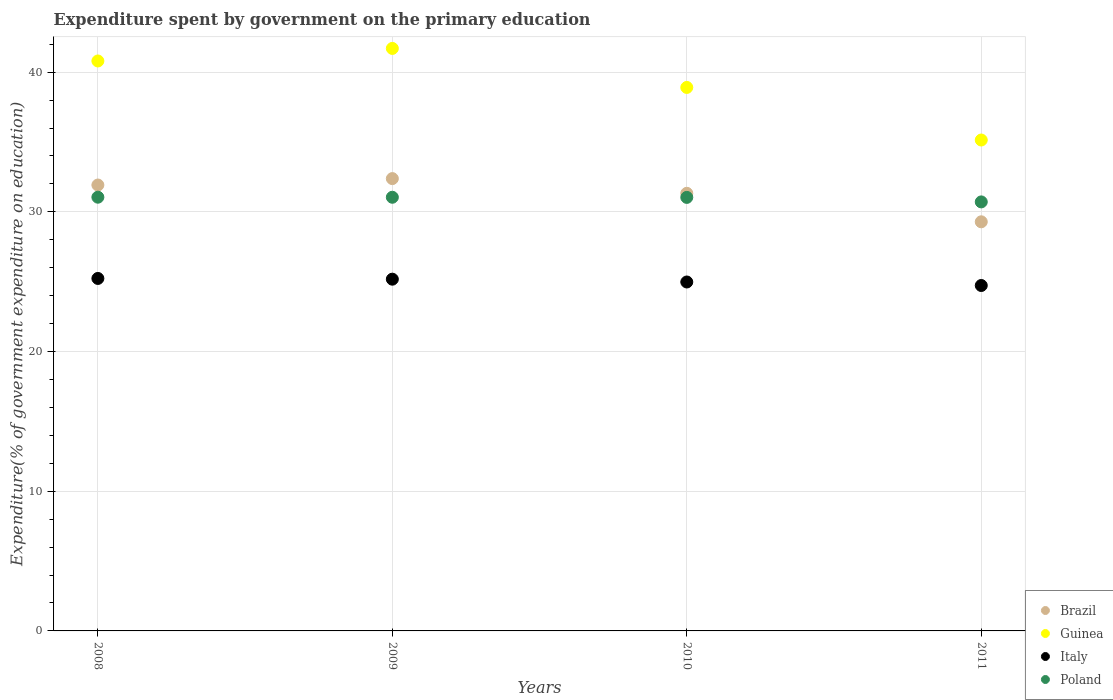Is the number of dotlines equal to the number of legend labels?
Give a very brief answer. Yes. What is the expenditure spent by government on the primary education in Italy in 2010?
Offer a terse response. 24.98. Across all years, what is the maximum expenditure spent by government on the primary education in Guinea?
Provide a succinct answer. 41.7. Across all years, what is the minimum expenditure spent by government on the primary education in Poland?
Make the answer very short. 30.71. In which year was the expenditure spent by government on the primary education in Guinea maximum?
Keep it short and to the point. 2009. In which year was the expenditure spent by government on the primary education in Poland minimum?
Provide a succinct answer. 2011. What is the total expenditure spent by government on the primary education in Italy in the graph?
Make the answer very short. 100.11. What is the difference between the expenditure spent by government on the primary education in Brazil in 2008 and that in 2010?
Make the answer very short. 0.59. What is the difference between the expenditure spent by government on the primary education in Brazil in 2011 and the expenditure spent by government on the primary education in Poland in 2009?
Provide a succinct answer. -1.76. What is the average expenditure spent by government on the primary education in Brazil per year?
Your answer should be compact. 31.23. In the year 2010, what is the difference between the expenditure spent by government on the primary education in Brazil and expenditure spent by government on the primary education in Poland?
Keep it short and to the point. 0.29. In how many years, is the expenditure spent by government on the primary education in Guinea greater than 34 %?
Make the answer very short. 4. What is the ratio of the expenditure spent by government on the primary education in Poland in 2009 to that in 2010?
Make the answer very short. 1. Is the expenditure spent by government on the primary education in Italy in 2009 less than that in 2010?
Your response must be concise. No. What is the difference between the highest and the second highest expenditure spent by government on the primary education in Poland?
Offer a terse response. 0. What is the difference between the highest and the lowest expenditure spent by government on the primary education in Guinea?
Give a very brief answer. 6.56. In how many years, is the expenditure spent by government on the primary education in Poland greater than the average expenditure spent by government on the primary education in Poland taken over all years?
Make the answer very short. 3. Is it the case that in every year, the sum of the expenditure spent by government on the primary education in Brazil and expenditure spent by government on the primary education in Italy  is greater than the expenditure spent by government on the primary education in Poland?
Offer a terse response. Yes. Is the expenditure spent by government on the primary education in Italy strictly less than the expenditure spent by government on the primary education in Guinea over the years?
Give a very brief answer. Yes. What is the difference between two consecutive major ticks on the Y-axis?
Give a very brief answer. 10. Does the graph contain any zero values?
Provide a succinct answer. No. How many legend labels are there?
Give a very brief answer. 4. What is the title of the graph?
Your answer should be very brief. Expenditure spent by government on the primary education. What is the label or title of the Y-axis?
Keep it short and to the point. Expenditure(% of government expenditure on education). What is the Expenditure(% of government expenditure on education) in Brazil in 2008?
Provide a short and direct response. 31.92. What is the Expenditure(% of government expenditure on education) of Guinea in 2008?
Provide a succinct answer. 40.8. What is the Expenditure(% of government expenditure on education) of Italy in 2008?
Give a very brief answer. 25.23. What is the Expenditure(% of government expenditure on education) in Poland in 2008?
Ensure brevity in your answer.  31.05. What is the Expenditure(% of government expenditure on education) in Brazil in 2009?
Ensure brevity in your answer.  32.38. What is the Expenditure(% of government expenditure on education) in Guinea in 2009?
Provide a succinct answer. 41.7. What is the Expenditure(% of government expenditure on education) in Italy in 2009?
Your answer should be compact. 25.18. What is the Expenditure(% of government expenditure on education) in Poland in 2009?
Give a very brief answer. 31.04. What is the Expenditure(% of government expenditure on education) in Brazil in 2010?
Provide a short and direct response. 31.33. What is the Expenditure(% of government expenditure on education) in Guinea in 2010?
Offer a terse response. 38.9. What is the Expenditure(% of government expenditure on education) in Italy in 2010?
Provide a short and direct response. 24.98. What is the Expenditure(% of government expenditure on education) in Poland in 2010?
Your answer should be very brief. 31.03. What is the Expenditure(% of government expenditure on education) of Brazil in 2011?
Ensure brevity in your answer.  29.29. What is the Expenditure(% of government expenditure on education) of Guinea in 2011?
Offer a terse response. 35.14. What is the Expenditure(% of government expenditure on education) in Italy in 2011?
Your answer should be compact. 24.73. What is the Expenditure(% of government expenditure on education) in Poland in 2011?
Provide a succinct answer. 30.71. Across all years, what is the maximum Expenditure(% of government expenditure on education) of Brazil?
Your response must be concise. 32.38. Across all years, what is the maximum Expenditure(% of government expenditure on education) of Guinea?
Keep it short and to the point. 41.7. Across all years, what is the maximum Expenditure(% of government expenditure on education) of Italy?
Give a very brief answer. 25.23. Across all years, what is the maximum Expenditure(% of government expenditure on education) in Poland?
Offer a terse response. 31.05. Across all years, what is the minimum Expenditure(% of government expenditure on education) in Brazil?
Provide a short and direct response. 29.29. Across all years, what is the minimum Expenditure(% of government expenditure on education) in Guinea?
Provide a succinct answer. 35.14. Across all years, what is the minimum Expenditure(% of government expenditure on education) of Italy?
Provide a succinct answer. 24.73. Across all years, what is the minimum Expenditure(% of government expenditure on education) in Poland?
Make the answer very short. 30.71. What is the total Expenditure(% of government expenditure on education) of Brazil in the graph?
Offer a terse response. 124.91. What is the total Expenditure(% of government expenditure on education) in Guinea in the graph?
Your answer should be very brief. 156.54. What is the total Expenditure(% of government expenditure on education) of Italy in the graph?
Give a very brief answer. 100.11. What is the total Expenditure(% of government expenditure on education) of Poland in the graph?
Ensure brevity in your answer.  123.83. What is the difference between the Expenditure(% of government expenditure on education) in Brazil in 2008 and that in 2009?
Offer a very short reply. -0.46. What is the difference between the Expenditure(% of government expenditure on education) of Guinea in 2008 and that in 2009?
Your answer should be compact. -0.9. What is the difference between the Expenditure(% of government expenditure on education) of Italy in 2008 and that in 2009?
Your answer should be very brief. 0.05. What is the difference between the Expenditure(% of government expenditure on education) of Poland in 2008 and that in 2009?
Offer a terse response. 0. What is the difference between the Expenditure(% of government expenditure on education) of Brazil in 2008 and that in 2010?
Keep it short and to the point. 0.59. What is the difference between the Expenditure(% of government expenditure on education) in Guinea in 2008 and that in 2010?
Keep it short and to the point. 1.89. What is the difference between the Expenditure(% of government expenditure on education) in Italy in 2008 and that in 2010?
Offer a very short reply. 0.25. What is the difference between the Expenditure(% of government expenditure on education) in Poland in 2008 and that in 2010?
Ensure brevity in your answer.  0.01. What is the difference between the Expenditure(% of government expenditure on education) in Brazil in 2008 and that in 2011?
Offer a terse response. 2.63. What is the difference between the Expenditure(% of government expenditure on education) of Guinea in 2008 and that in 2011?
Your response must be concise. 5.66. What is the difference between the Expenditure(% of government expenditure on education) of Italy in 2008 and that in 2011?
Keep it short and to the point. 0.5. What is the difference between the Expenditure(% of government expenditure on education) of Poland in 2008 and that in 2011?
Keep it short and to the point. 0.34. What is the difference between the Expenditure(% of government expenditure on education) of Brazil in 2009 and that in 2010?
Offer a very short reply. 1.05. What is the difference between the Expenditure(% of government expenditure on education) of Guinea in 2009 and that in 2010?
Provide a succinct answer. 2.79. What is the difference between the Expenditure(% of government expenditure on education) of Italy in 2009 and that in 2010?
Offer a terse response. 0.2. What is the difference between the Expenditure(% of government expenditure on education) of Poland in 2009 and that in 2010?
Provide a short and direct response. 0.01. What is the difference between the Expenditure(% of government expenditure on education) in Brazil in 2009 and that in 2011?
Your answer should be very brief. 3.09. What is the difference between the Expenditure(% of government expenditure on education) in Guinea in 2009 and that in 2011?
Provide a short and direct response. 6.56. What is the difference between the Expenditure(% of government expenditure on education) of Italy in 2009 and that in 2011?
Your answer should be very brief. 0.45. What is the difference between the Expenditure(% of government expenditure on education) in Poland in 2009 and that in 2011?
Give a very brief answer. 0.33. What is the difference between the Expenditure(% of government expenditure on education) of Brazil in 2010 and that in 2011?
Your answer should be compact. 2.04. What is the difference between the Expenditure(% of government expenditure on education) in Guinea in 2010 and that in 2011?
Make the answer very short. 3.76. What is the difference between the Expenditure(% of government expenditure on education) in Italy in 2010 and that in 2011?
Your response must be concise. 0.25. What is the difference between the Expenditure(% of government expenditure on education) of Poland in 2010 and that in 2011?
Keep it short and to the point. 0.32. What is the difference between the Expenditure(% of government expenditure on education) in Brazil in 2008 and the Expenditure(% of government expenditure on education) in Guinea in 2009?
Your answer should be very brief. -9.78. What is the difference between the Expenditure(% of government expenditure on education) of Brazil in 2008 and the Expenditure(% of government expenditure on education) of Italy in 2009?
Your response must be concise. 6.74. What is the difference between the Expenditure(% of government expenditure on education) in Brazil in 2008 and the Expenditure(% of government expenditure on education) in Poland in 2009?
Offer a very short reply. 0.88. What is the difference between the Expenditure(% of government expenditure on education) of Guinea in 2008 and the Expenditure(% of government expenditure on education) of Italy in 2009?
Offer a terse response. 15.62. What is the difference between the Expenditure(% of government expenditure on education) of Guinea in 2008 and the Expenditure(% of government expenditure on education) of Poland in 2009?
Provide a succinct answer. 9.76. What is the difference between the Expenditure(% of government expenditure on education) in Italy in 2008 and the Expenditure(% of government expenditure on education) in Poland in 2009?
Keep it short and to the point. -5.81. What is the difference between the Expenditure(% of government expenditure on education) in Brazil in 2008 and the Expenditure(% of government expenditure on education) in Guinea in 2010?
Your response must be concise. -6.99. What is the difference between the Expenditure(% of government expenditure on education) of Brazil in 2008 and the Expenditure(% of government expenditure on education) of Italy in 2010?
Ensure brevity in your answer.  6.94. What is the difference between the Expenditure(% of government expenditure on education) of Brazil in 2008 and the Expenditure(% of government expenditure on education) of Poland in 2010?
Offer a very short reply. 0.89. What is the difference between the Expenditure(% of government expenditure on education) in Guinea in 2008 and the Expenditure(% of government expenditure on education) in Italy in 2010?
Make the answer very short. 15.82. What is the difference between the Expenditure(% of government expenditure on education) in Guinea in 2008 and the Expenditure(% of government expenditure on education) in Poland in 2010?
Keep it short and to the point. 9.77. What is the difference between the Expenditure(% of government expenditure on education) of Italy in 2008 and the Expenditure(% of government expenditure on education) of Poland in 2010?
Offer a terse response. -5.8. What is the difference between the Expenditure(% of government expenditure on education) in Brazil in 2008 and the Expenditure(% of government expenditure on education) in Guinea in 2011?
Provide a succinct answer. -3.22. What is the difference between the Expenditure(% of government expenditure on education) in Brazil in 2008 and the Expenditure(% of government expenditure on education) in Italy in 2011?
Ensure brevity in your answer.  7.19. What is the difference between the Expenditure(% of government expenditure on education) in Brazil in 2008 and the Expenditure(% of government expenditure on education) in Poland in 2011?
Keep it short and to the point. 1.21. What is the difference between the Expenditure(% of government expenditure on education) in Guinea in 2008 and the Expenditure(% of government expenditure on education) in Italy in 2011?
Your answer should be compact. 16.07. What is the difference between the Expenditure(% of government expenditure on education) in Guinea in 2008 and the Expenditure(% of government expenditure on education) in Poland in 2011?
Offer a very short reply. 10.09. What is the difference between the Expenditure(% of government expenditure on education) in Italy in 2008 and the Expenditure(% of government expenditure on education) in Poland in 2011?
Offer a terse response. -5.48. What is the difference between the Expenditure(% of government expenditure on education) in Brazil in 2009 and the Expenditure(% of government expenditure on education) in Guinea in 2010?
Make the answer very short. -6.53. What is the difference between the Expenditure(% of government expenditure on education) of Brazil in 2009 and the Expenditure(% of government expenditure on education) of Italy in 2010?
Offer a terse response. 7.4. What is the difference between the Expenditure(% of government expenditure on education) in Brazil in 2009 and the Expenditure(% of government expenditure on education) in Poland in 2010?
Offer a terse response. 1.35. What is the difference between the Expenditure(% of government expenditure on education) of Guinea in 2009 and the Expenditure(% of government expenditure on education) of Italy in 2010?
Make the answer very short. 16.72. What is the difference between the Expenditure(% of government expenditure on education) of Guinea in 2009 and the Expenditure(% of government expenditure on education) of Poland in 2010?
Provide a short and direct response. 10.66. What is the difference between the Expenditure(% of government expenditure on education) of Italy in 2009 and the Expenditure(% of government expenditure on education) of Poland in 2010?
Give a very brief answer. -5.85. What is the difference between the Expenditure(% of government expenditure on education) of Brazil in 2009 and the Expenditure(% of government expenditure on education) of Guinea in 2011?
Your answer should be very brief. -2.76. What is the difference between the Expenditure(% of government expenditure on education) in Brazil in 2009 and the Expenditure(% of government expenditure on education) in Italy in 2011?
Provide a short and direct response. 7.65. What is the difference between the Expenditure(% of government expenditure on education) in Brazil in 2009 and the Expenditure(% of government expenditure on education) in Poland in 2011?
Your answer should be compact. 1.67. What is the difference between the Expenditure(% of government expenditure on education) of Guinea in 2009 and the Expenditure(% of government expenditure on education) of Italy in 2011?
Your answer should be very brief. 16.97. What is the difference between the Expenditure(% of government expenditure on education) in Guinea in 2009 and the Expenditure(% of government expenditure on education) in Poland in 2011?
Make the answer very short. 10.99. What is the difference between the Expenditure(% of government expenditure on education) in Italy in 2009 and the Expenditure(% of government expenditure on education) in Poland in 2011?
Keep it short and to the point. -5.53. What is the difference between the Expenditure(% of government expenditure on education) of Brazil in 2010 and the Expenditure(% of government expenditure on education) of Guinea in 2011?
Make the answer very short. -3.81. What is the difference between the Expenditure(% of government expenditure on education) in Brazil in 2010 and the Expenditure(% of government expenditure on education) in Italy in 2011?
Offer a very short reply. 6.6. What is the difference between the Expenditure(% of government expenditure on education) of Brazil in 2010 and the Expenditure(% of government expenditure on education) of Poland in 2011?
Keep it short and to the point. 0.62. What is the difference between the Expenditure(% of government expenditure on education) of Guinea in 2010 and the Expenditure(% of government expenditure on education) of Italy in 2011?
Ensure brevity in your answer.  14.18. What is the difference between the Expenditure(% of government expenditure on education) of Guinea in 2010 and the Expenditure(% of government expenditure on education) of Poland in 2011?
Offer a very short reply. 8.19. What is the difference between the Expenditure(% of government expenditure on education) in Italy in 2010 and the Expenditure(% of government expenditure on education) in Poland in 2011?
Keep it short and to the point. -5.73. What is the average Expenditure(% of government expenditure on education) in Brazil per year?
Give a very brief answer. 31.23. What is the average Expenditure(% of government expenditure on education) of Guinea per year?
Offer a very short reply. 39.14. What is the average Expenditure(% of government expenditure on education) of Italy per year?
Make the answer very short. 25.03. What is the average Expenditure(% of government expenditure on education) of Poland per year?
Offer a terse response. 30.96. In the year 2008, what is the difference between the Expenditure(% of government expenditure on education) in Brazil and Expenditure(% of government expenditure on education) in Guinea?
Offer a terse response. -8.88. In the year 2008, what is the difference between the Expenditure(% of government expenditure on education) in Brazil and Expenditure(% of government expenditure on education) in Italy?
Ensure brevity in your answer.  6.69. In the year 2008, what is the difference between the Expenditure(% of government expenditure on education) in Brazil and Expenditure(% of government expenditure on education) in Poland?
Make the answer very short. 0.87. In the year 2008, what is the difference between the Expenditure(% of government expenditure on education) of Guinea and Expenditure(% of government expenditure on education) of Italy?
Give a very brief answer. 15.57. In the year 2008, what is the difference between the Expenditure(% of government expenditure on education) in Guinea and Expenditure(% of government expenditure on education) in Poland?
Give a very brief answer. 9.75. In the year 2008, what is the difference between the Expenditure(% of government expenditure on education) of Italy and Expenditure(% of government expenditure on education) of Poland?
Make the answer very short. -5.82. In the year 2009, what is the difference between the Expenditure(% of government expenditure on education) of Brazil and Expenditure(% of government expenditure on education) of Guinea?
Make the answer very short. -9.32. In the year 2009, what is the difference between the Expenditure(% of government expenditure on education) of Brazil and Expenditure(% of government expenditure on education) of Italy?
Your response must be concise. 7.2. In the year 2009, what is the difference between the Expenditure(% of government expenditure on education) in Brazil and Expenditure(% of government expenditure on education) in Poland?
Keep it short and to the point. 1.34. In the year 2009, what is the difference between the Expenditure(% of government expenditure on education) of Guinea and Expenditure(% of government expenditure on education) of Italy?
Your answer should be compact. 16.52. In the year 2009, what is the difference between the Expenditure(% of government expenditure on education) of Guinea and Expenditure(% of government expenditure on education) of Poland?
Provide a succinct answer. 10.65. In the year 2009, what is the difference between the Expenditure(% of government expenditure on education) in Italy and Expenditure(% of government expenditure on education) in Poland?
Keep it short and to the point. -5.86. In the year 2010, what is the difference between the Expenditure(% of government expenditure on education) in Brazil and Expenditure(% of government expenditure on education) in Guinea?
Keep it short and to the point. -7.58. In the year 2010, what is the difference between the Expenditure(% of government expenditure on education) in Brazil and Expenditure(% of government expenditure on education) in Italy?
Make the answer very short. 6.35. In the year 2010, what is the difference between the Expenditure(% of government expenditure on education) of Brazil and Expenditure(% of government expenditure on education) of Poland?
Make the answer very short. 0.29. In the year 2010, what is the difference between the Expenditure(% of government expenditure on education) of Guinea and Expenditure(% of government expenditure on education) of Italy?
Keep it short and to the point. 13.93. In the year 2010, what is the difference between the Expenditure(% of government expenditure on education) in Guinea and Expenditure(% of government expenditure on education) in Poland?
Make the answer very short. 7.87. In the year 2010, what is the difference between the Expenditure(% of government expenditure on education) in Italy and Expenditure(% of government expenditure on education) in Poland?
Make the answer very short. -6.06. In the year 2011, what is the difference between the Expenditure(% of government expenditure on education) in Brazil and Expenditure(% of government expenditure on education) in Guinea?
Offer a very short reply. -5.86. In the year 2011, what is the difference between the Expenditure(% of government expenditure on education) in Brazil and Expenditure(% of government expenditure on education) in Italy?
Keep it short and to the point. 4.56. In the year 2011, what is the difference between the Expenditure(% of government expenditure on education) of Brazil and Expenditure(% of government expenditure on education) of Poland?
Make the answer very short. -1.43. In the year 2011, what is the difference between the Expenditure(% of government expenditure on education) in Guinea and Expenditure(% of government expenditure on education) in Italy?
Ensure brevity in your answer.  10.41. In the year 2011, what is the difference between the Expenditure(% of government expenditure on education) in Guinea and Expenditure(% of government expenditure on education) in Poland?
Make the answer very short. 4.43. In the year 2011, what is the difference between the Expenditure(% of government expenditure on education) of Italy and Expenditure(% of government expenditure on education) of Poland?
Your response must be concise. -5.98. What is the ratio of the Expenditure(% of government expenditure on education) in Brazil in 2008 to that in 2009?
Keep it short and to the point. 0.99. What is the ratio of the Expenditure(% of government expenditure on education) in Guinea in 2008 to that in 2009?
Your answer should be compact. 0.98. What is the ratio of the Expenditure(% of government expenditure on education) in Italy in 2008 to that in 2009?
Offer a very short reply. 1. What is the ratio of the Expenditure(% of government expenditure on education) of Poland in 2008 to that in 2009?
Offer a terse response. 1. What is the ratio of the Expenditure(% of government expenditure on education) in Brazil in 2008 to that in 2010?
Your answer should be compact. 1.02. What is the ratio of the Expenditure(% of government expenditure on education) of Guinea in 2008 to that in 2010?
Offer a terse response. 1.05. What is the ratio of the Expenditure(% of government expenditure on education) in Italy in 2008 to that in 2010?
Your answer should be very brief. 1.01. What is the ratio of the Expenditure(% of government expenditure on education) in Poland in 2008 to that in 2010?
Give a very brief answer. 1. What is the ratio of the Expenditure(% of government expenditure on education) of Brazil in 2008 to that in 2011?
Make the answer very short. 1.09. What is the ratio of the Expenditure(% of government expenditure on education) of Guinea in 2008 to that in 2011?
Provide a short and direct response. 1.16. What is the ratio of the Expenditure(% of government expenditure on education) of Italy in 2008 to that in 2011?
Provide a short and direct response. 1.02. What is the ratio of the Expenditure(% of government expenditure on education) in Brazil in 2009 to that in 2010?
Your response must be concise. 1.03. What is the ratio of the Expenditure(% of government expenditure on education) in Guinea in 2009 to that in 2010?
Give a very brief answer. 1.07. What is the ratio of the Expenditure(% of government expenditure on education) in Italy in 2009 to that in 2010?
Make the answer very short. 1.01. What is the ratio of the Expenditure(% of government expenditure on education) of Brazil in 2009 to that in 2011?
Keep it short and to the point. 1.11. What is the ratio of the Expenditure(% of government expenditure on education) of Guinea in 2009 to that in 2011?
Keep it short and to the point. 1.19. What is the ratio of the Expenditure(% of government expenditure on education) in Italy in 2009 to that in 2011?
Ensure brevity in your answer.  1.02. What is the ratio of the Expenditure(% of government expenditure on education) of Poland in 2009 to that in 2011?
Offer a terse response. 1.01. What is the ratio of the Expenditure(% of government expenditure on education) in Brazil in 2010 to that in 2011?
Provide a short and direct response. 1.07. What is the ratio of the Expenditure(% of government expenditure on education) in Guinea in 2010 to that in 2011?
Your answer should be compact. 1.11. What is the ratio of the Expenditure(% of government expenditure on education) in Italy in 2010 to that in 2011?
Provide a short and direct response. 1.01. What is the ratio of the Expenditure(% of government expenditure on education) of Poland in 2010 to that in 2011?
Your answer should be very brief. 1.01. What is the difference between the highest and the second highest Expenditure(% of government expenditure on education) of Brazil?
Give a very brief answer. 0.46. What is the difference between the highest and the second highest Expenditure(% of government expenditure on education) in Guinea?
Your response must be concise. 0.9. What is the difference between the highest and the second highest Expenditure(% of government expenditure on education) of Italy?
Offer a very short reply. 0.05. What is the difference between the highest and the second highest Expenditure(% of government expenditure on education) in Poland?
Your answer should be compact. 0. What is the difference between the highest and the lowest Expenditure(% of government expenditure on education) of Brazil?
Make the answer very short. 3.09. What is the difference between the highest and the lowest Expenditure(% of government expenditure on education) in Guinea?
Offer a very short reply. 6.56. What is the difference between the highest and the lowest Expenditure(% of government expenditure on education) of Italy?
Your answer should be very brief. 0.5. What is the difference between the highest and the lowest Expenditure(% of government expenditure on education) in Poland?
Your answer should be very brief. 0.34. 